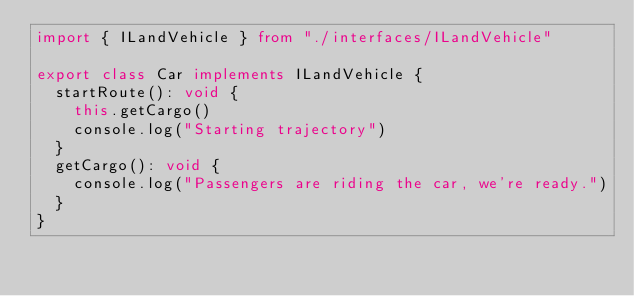Convert code to text. <code><loc_0><loc_0><loc_500><loc_500><_TypeScript_>import { ILandVehicle } from "./interfaces/ILandVehicle"

export class Car implements ILandVehicle {
  startRoute(): void {
    this.getCargo()
    console.log("Starting trajectory")
  }
  getCargo(): void {
    console.log("Passengers are riding the car, we're ready.")
  }
}
</code> 